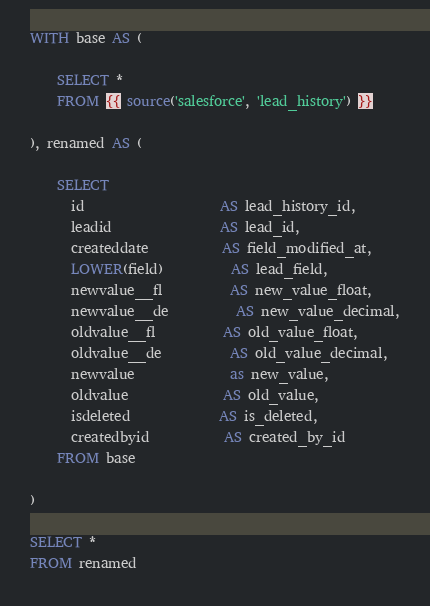<code> <loc_0><loc_0><loc_500><loc_500><_SQL_>WITH base AS (

    SELECT *
    FROM {{ source('salesforce', 'lead_history') }}

), renamed AS (

    SELECT
      id                    AS lead_history_id,
      leadid                AS lead_id,
      createddate           AS field_modified_at,
      LOWER(field)          AS lead_field,
      newvalue__fl          AS new_value_float,
      newvalue__de          AS new_value_decimal,
      oldvalue__fl          AS old_value_float,
      oldvalue__de          AS old_value_decimal,
      newvalue              as new_value,
      oldvalue              AS old_value,
      isdeleted             AS is_deleted,
      createdbyid           AS created_by_id
    FROM base

)

SELECT *
FROM renamed
</code> 